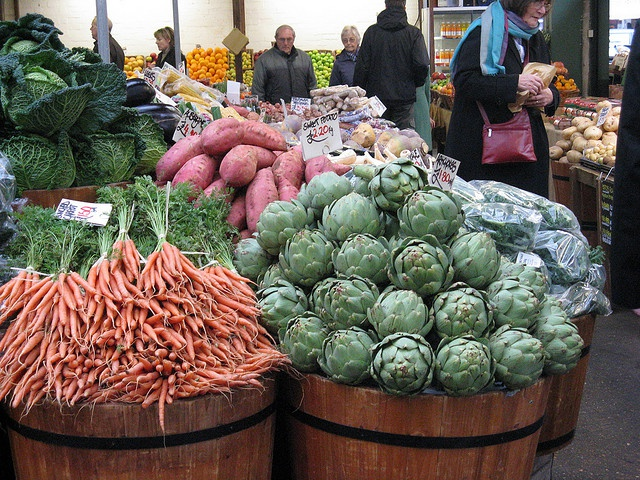Describe the objects in this image and their specific colors. I can see carrot in black, lightpink, maroon, and brown tones, people in black, brown, gray, and maroon tones, people in black, gray, and purple tones, carrot in black, lightpink, maroon, and brown tones, and people in black and gray tones in this image. 